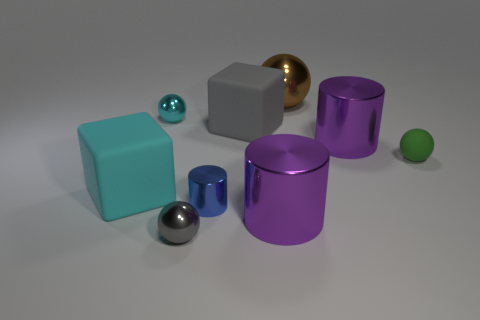What is the shape of the blue metallic object in front of the small ball that is to the right of the purple cylinder that is left of the big ball?
Give a very brief answer. Cylinder. Do the small gray metallic object and the green matte object have the same shape?
Provide a short and direct response. Yes. What is the shape of the small green thing that is on the right side of the big thing that is behind the big gray rubber object?
Provide a succinct answer. Sphere. Is there a tiny green metal ball?
Your response must be concise. No. What number of large gray matte cubes are on the right side of the purple cylinder that is in front of the cyan thing in front of the green ball?
Provide a short and direct response. 0. There is a small blue metal thing; does it have the same shape as the big metal thing in front of the tiny metallic cylinder?
Offer a very short reply. Yes. Is the number of tiny blue shiny things greater than the number of cyan things?
Ensure brevity in your answer.  No. Are there any other things that have the same size as the blue cylinder?
Make the answer very short. Yes. Does the tiny thing to the right of the tiny cylinder have the same shape as the large gray matte thing?
Offer a terse response. No. Are there more gray cubes behind the big sphere than metal balls?
Make the answer very short. No. 